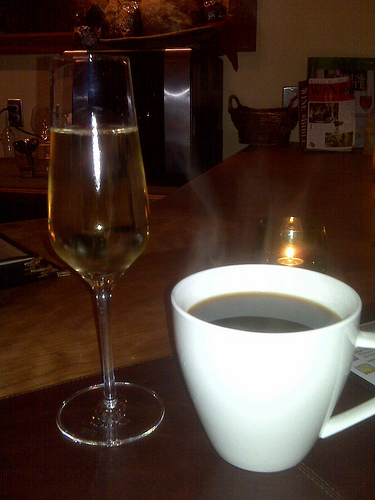<image>
Is there a wine in the cup? No. The wine is not contained within the cup. These objects have a different spatial relationship. 